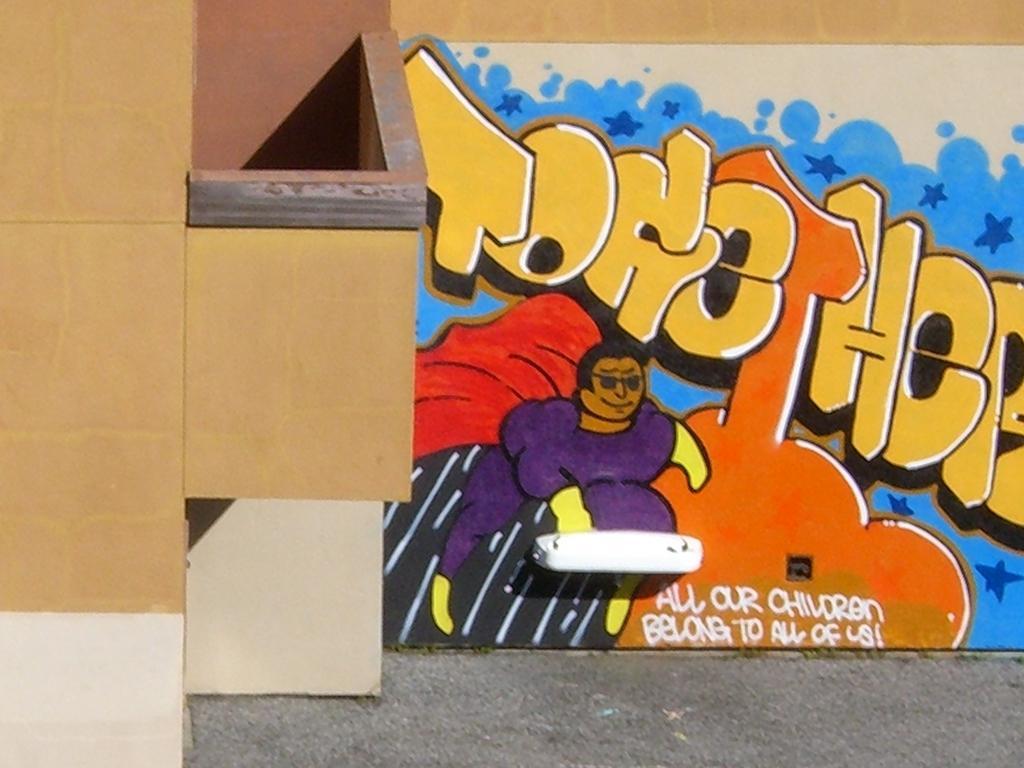Can you describe this image briefly? In this image I can see the wall painting. To the left I can see the board. In the painting I can see the text all our children belong to all of us is written on it. And the painting is colorful. I can also see the person in the painting. 